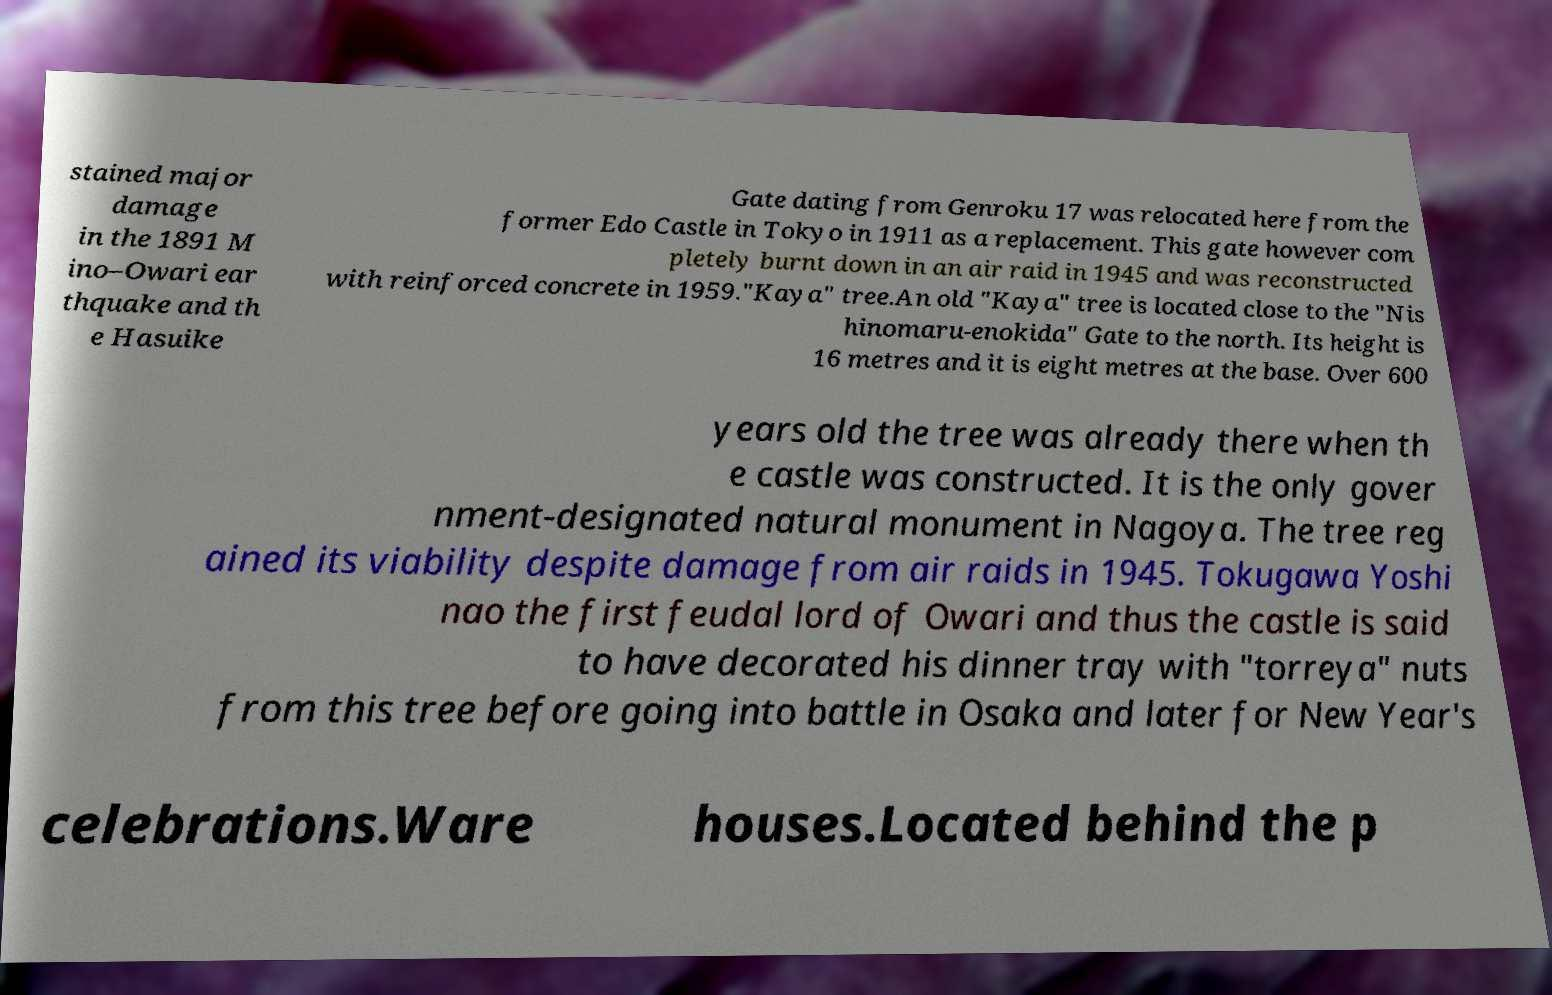Please read and relay the text visible in this image. What does it say? stained major damage in the 1891 M ino–Owari ear thquake and th e Hasuike Gate dating from Genroku 17 was relocated here from the former Edo Castle in Tokyo in 1911 as a replacement. This gate however com pletely burnt down in an air raid in 1945 and was reconstructed with reinforced concrete in 1959."Kaya" tree.An old "Kaya" tree is located close to the "Nis hinomaru-enokida" Gate to the north. Its height is 16 metres and it is eight metres at the base. Over 600 years old the tree was already there when th e castle was constructed. It is the only gover nment-designated natural monument in Nagoya. The tree reg ained its viability despite damage from air raids in 1945. Tokugawa Yoshi nao the first feudal lord of Owari and thus the castle is said to have decorated his dinner tray with "torreya" nuts from this tree before going into battle in Osaka and later for New Year's celebrations.Ware houses.Located behind the p 